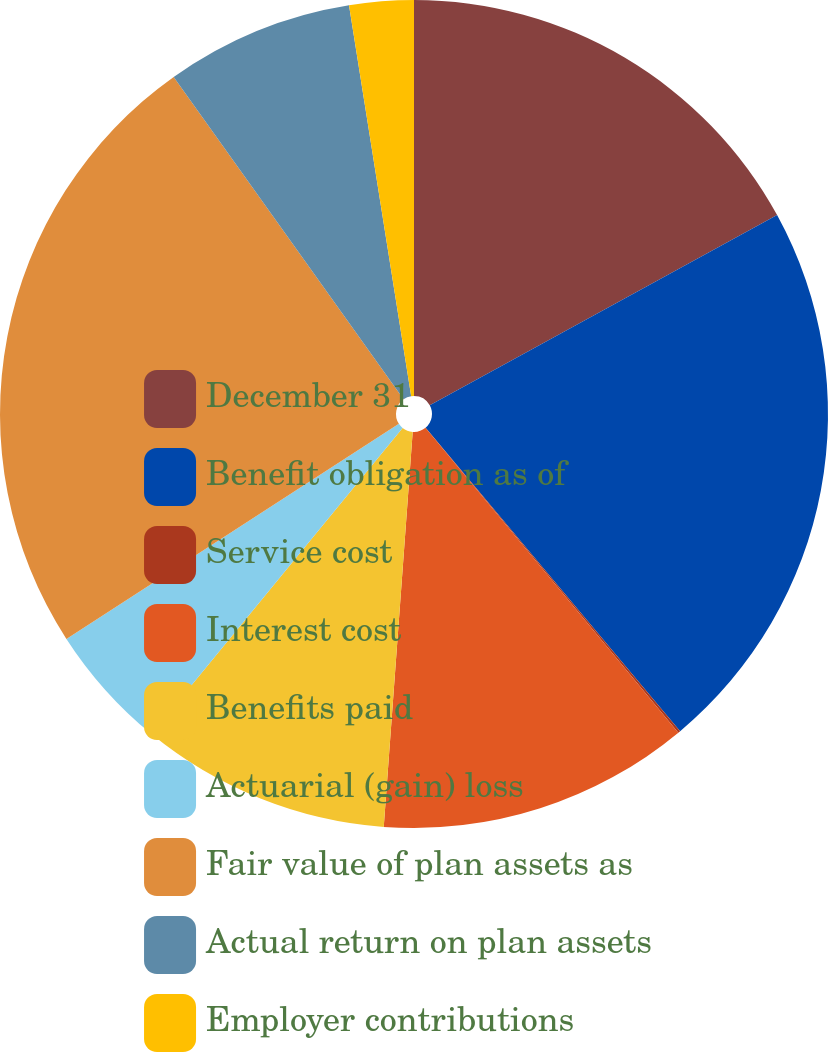Convert chart to OTSL. <chart><loc_0><loc_0><loc_500><loc_500><pie_chart><fcel>December 31<fcel>Benefit obligation as of<fcel>Service cost<fcel>Interest cost<fcel>Benefits paid<fcel>Actuarial (gain) loss<fcel>Fair value of plan assets as<fcel>Actual return on plan assets<fcel>Employer contributions<nl><fcel>17.03%<fcel>21.87%<fcel>0.09%<fcel>12.19%<fcel>9.77%<fcel>4.93%<fcel>24.29%<fcel>7.35%<fcel>2.51%<nl></chart> 